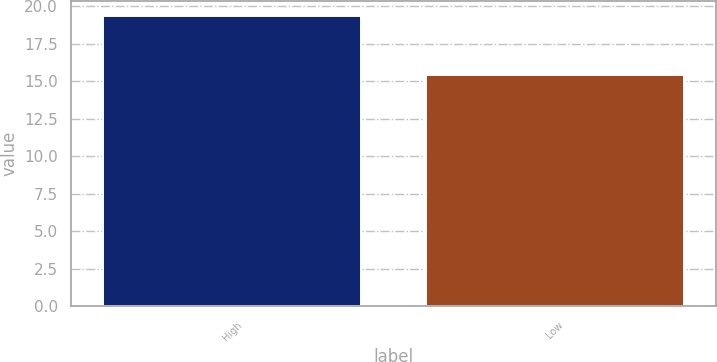Convert chart. <chart><loc_0><loc_0><loc_500><loc_500><bar_chart><fcel>High<fcel>Low<nl><fcel>19.39<fcel>15.45<nl></chart> 